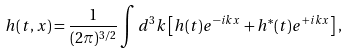Convert formula to latex. <formula><loc_0><loc_0><loc_500><loc_500>h ( t , x ) = \frac { 1 } { ( 2 \pi ) ^ { 3 / 2 } } \int d ^ { 3 } k \left [ h ( t ) e ^ { - i k x } + h ^ { * } ( t ) e ^ { + i k x } \right ] ,</formula> 